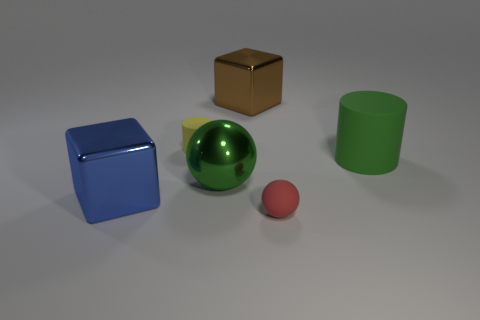Are the large thing to the left of the tiny yellow object and the cylinder that is to the left of the red ball made of the same material?
Ensure brevity in your answer.  No. There is a green thing to the left of the big shiny block that is on the right side of the cylinder behind the large green cylinder; what shape is it?
Keep it short and to the point. Sphere. Is the number of big blue matte cubes greater than the number of brown cubes?
Keep it short and to the point. No. Is there a tiny cube?
Your response must be concise. No. How many objects are tiny things to the left of the big green sphere or yellow things in front of the brown thing?
Give a very brief answer. 1. Do the shiny ball and the tiny rubber cylinder have the same color?
Provide a succinct answer. No. Are there fewer cyan metal objects than rubber cylinders?
Keep it short and to the point. Yes. There is a large blue metallic block; are there any brown metallic blocks to the left of it?
Provide a short and direct response. No. Does the yellow object have the same material as the large ball?
Keep it short and to the point. No. What color is the other small rubber object that is the same shape as the green rubber thing?
Make the answer very short. Yellow. 